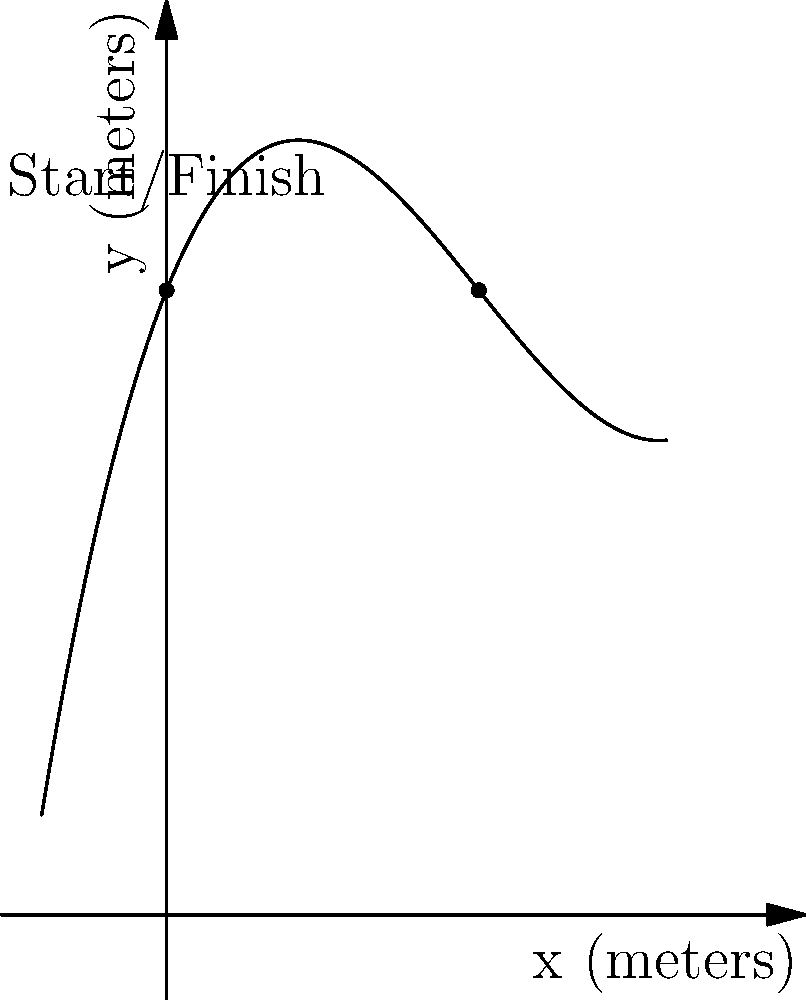At the New Armory, a section of the indoor track is modeled by the polynomial function $f(x) = 0.05x^3 - 0.75x^2 + 2.5x + 10$, where $x$ and $f(x)$ are measured in meters. The start and finish line is at $x = 0$. What is the maximum lateral displacement of the track from the start/finish line, and at what distance along the x-axis does it occur? To find the maximum lateral displacement, we need to find the maximum value of $f(x)$ in the relevant domain.

1) First, let's find the critical points by taking the derivative and setting it equal to zero:
   $f'(x) = 0.15x^2 - 1.5x + 2.5$
   $0.15x^2 - 1.5x + 2.5 = 0$

2) This is a quadratic equation. We can solve it using the quadratic formula:
   $x = \frac{-b \pm \sqrt{b^2 - 4ac}}{2a}$
   $x = \frac{1.5 \pm \sqrt{1.5^2 - 4(0.15)(2.5)}}{2(0.15)}$
   $x \approx 5.59$ or $x \approx 2.41$

3) We also need to consider the endpoints of our domain. The start/finish line is at $x = 0$, and the graph shows the track up to about $x = 8$.

4) Let's evaluate $f(x)$ at these critical points and endpoints:
   $f(0) = 10$
   $f(2.41) \approx 11.76$
   $f(5.59) \approx 11.76$
   $f(8) \approx 10$

5) The maximum value occurs at both $x \approx 2.41$ and $x \approx 5.59$, with a y-value of approximately 11.76 meters.

6) The lateral displacement is the difference between this maximum and the start/finish line height:
   $11.76 - 10 = 1.76$ meters

Therefore, the maximum lateral displacement is about 1.76 meters, occurring at approximately 2.41 meters and 5.59 meters along the x-axis.
Answer: 1.76 meters; at x ≈ 2.41 m and 5.59 m 